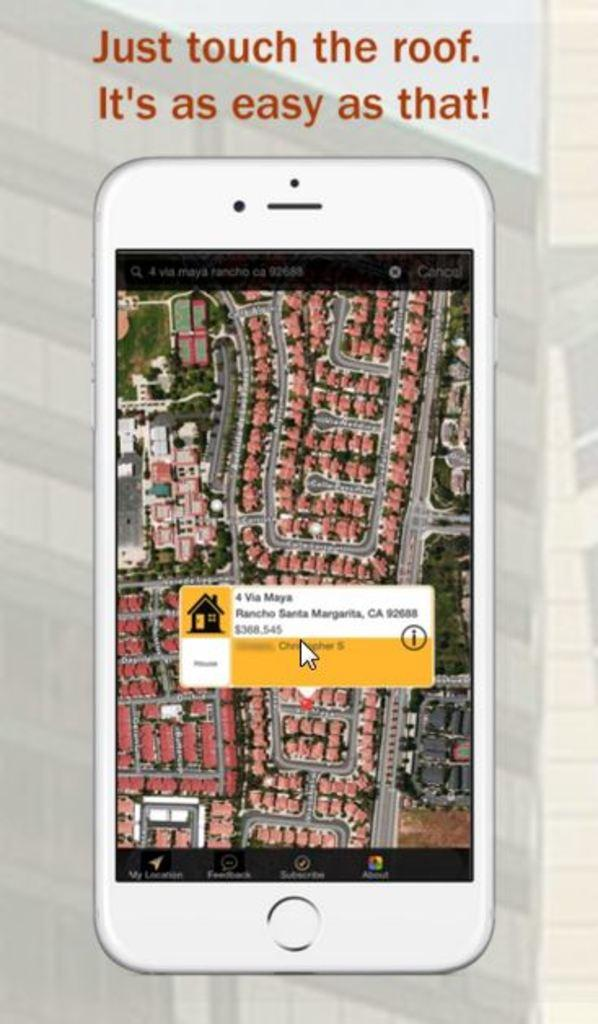What is featured on the poster in the image? There is a poster in the image, and it has an image of a mobile phone. What else can be seen on the poster besides the mobile phone? There is text on the poster. What is displayed on the mobile phone's screen in the image? The mobile phone's screen displays a map. How many fish can be seen swimming in the air in the image? There are no fish or air present in the image; it features a poster with a mobile phone and text. 